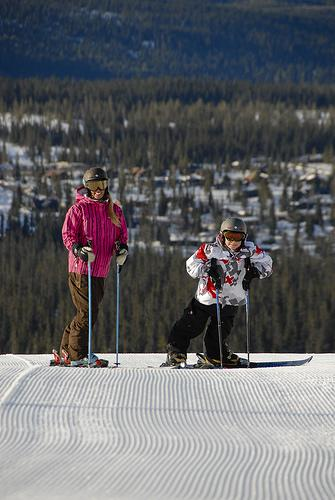Question: what are they holding?
Choices:
A. Brooms.
B. Ski poles.
C. Baseball bats.
D. Golf clubs.
Answer with the letter. Answer: B Question: what are the people doing?
Choices:
A. Running.
B. Jumping.
C. Swimming.
D. Skiing.
Answer with the letter. Answer: D Question: where are the kids?
Choices:
A. On the ferris wheel.
B. On the street.
C. On the bus.
D. On a ski slope.
Answer with the letter. Answer: D Question: when was the picture taken?
Choices:
A. In summer.
B. In winter.
C. In spring.
D. In fall.
Answer with the letter. Answer: B Question: who has a pink jacket?
Choices:
A. The little girl.
B. The teenage girl.
C. The elderly lady.
D. The adult.
Answer with the letter. Answer: D Question: who has goggles on?
Choices:
A. The child swimming.
B. Both do.
C. The snorkeler.
D. The welder.
Answer with the letter. Answer: B Question: why are they wearing skis?
Choices:
A. For a sports magazine.
B. To competer in a race.
C. To ski.
D. To save someone in an avalanche.
Answer with the letter. Answer: C Question: why is the snow grooved?
Choices:
A. Animal tracks.
B. The snow has been groomed.
C. Ski tracks.
D. Car tracks.
Answer with the letter. Answer: B 